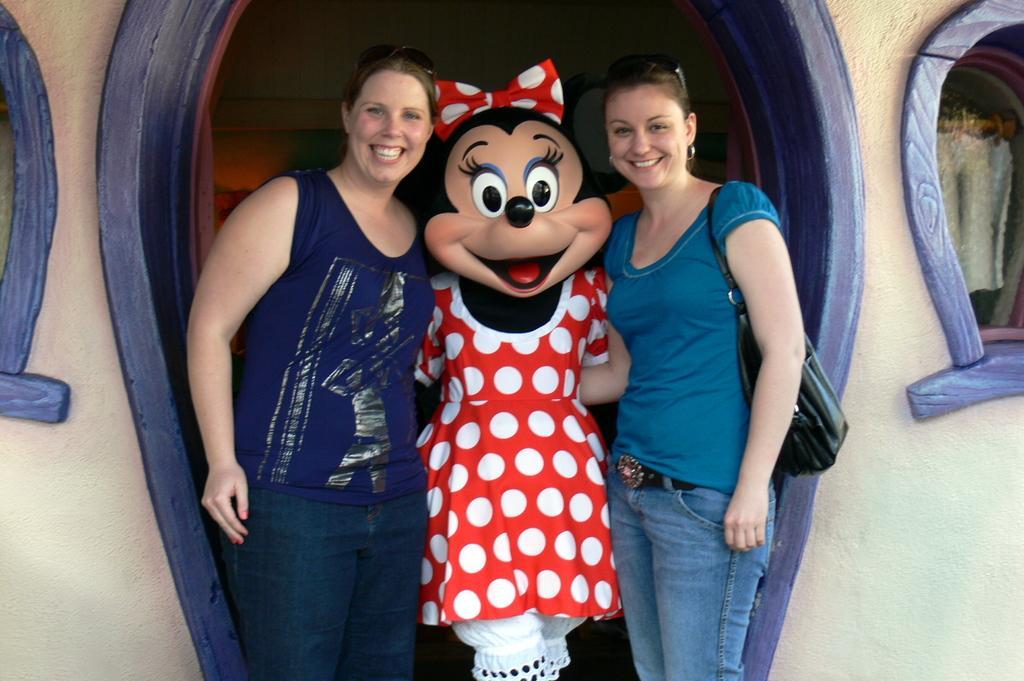Could you give a brief overview of what you see in this image? In this picture there are two women standing and smiling, in between these two women there is a person standing and wore costume. We can see wall and windows. 